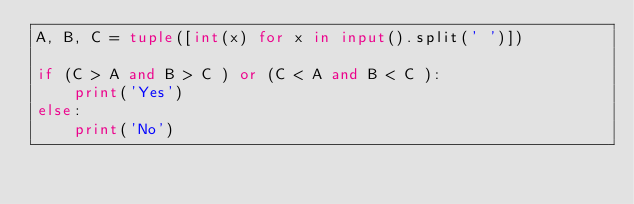<code> <loc_0><loc_0><loc_500><loc_500><_Python_>A, B, C = tuple([int(x) for x in input().split(' ')])

if (C > A and B > C ) or (C < A and B < C ):
    print('Yes')
else:
    print('No')</code> 